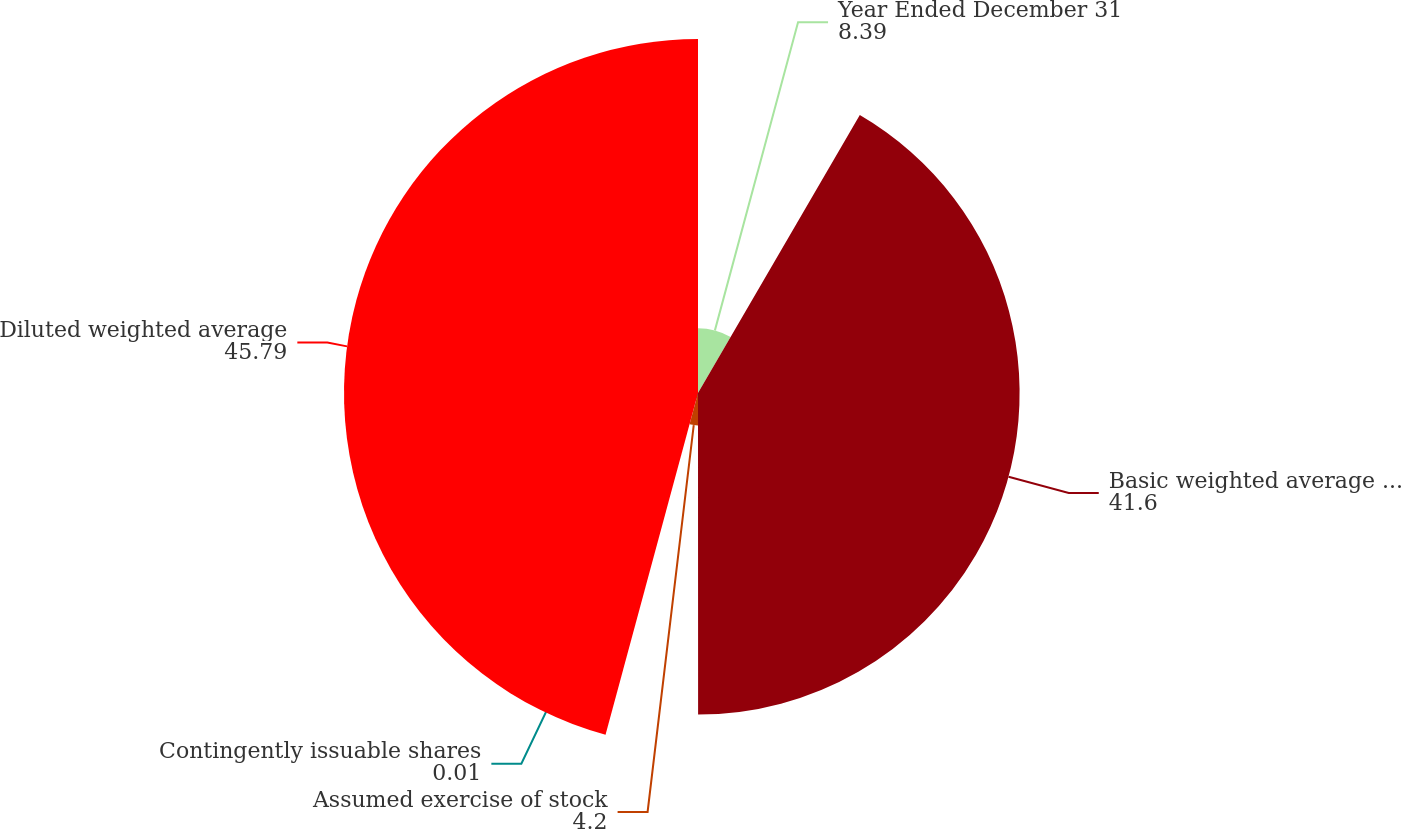Convert chart to OTSL. <chart><loc_0><loc_0><loc_500><loc_500><pie_chart><fcel>Year Ended December 31<fcel>Basic weighted average shares<fcel>Assumed exercise of stock<fcel>Contingently issuable shares<fcel>Diluted weighted average<nl><fcel>8.39%<fcel>41.6%<fcel>4.2%<fcel>0.01%<fcel>45.79%<nl></chart> 